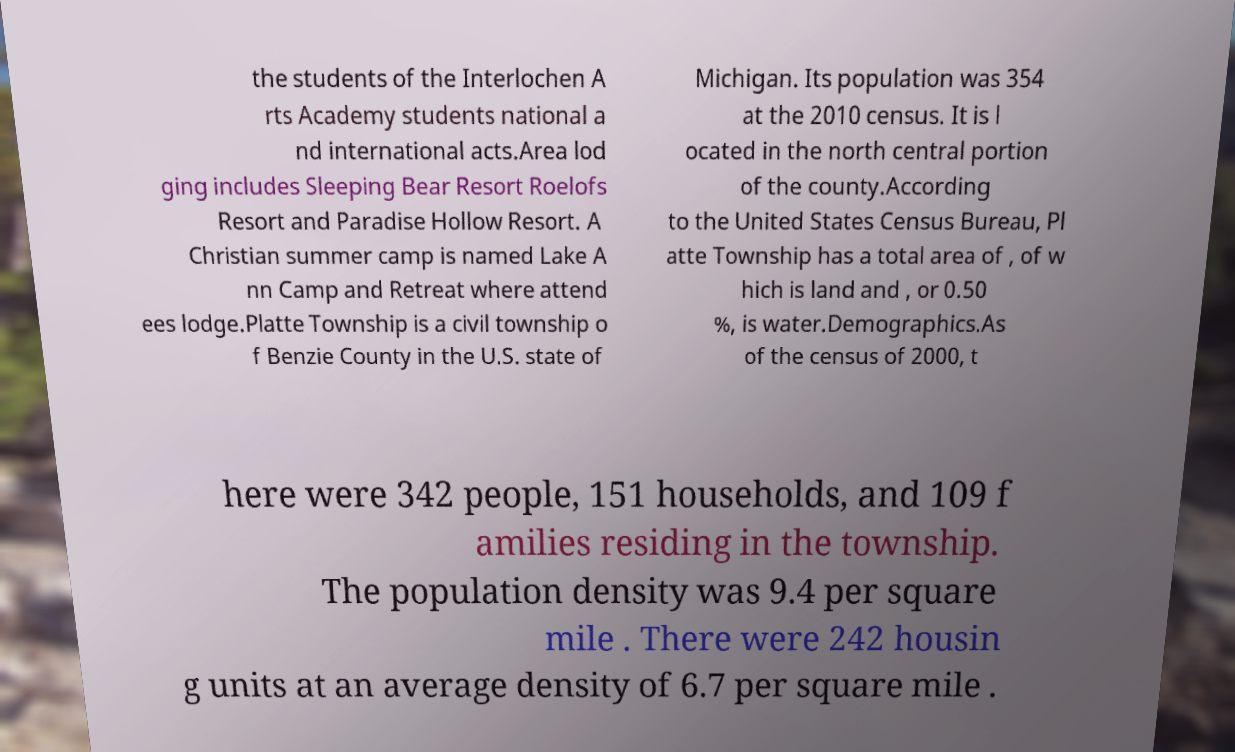Please read and relay the text visible in this image. What does it say? the students of the Interlochen A rts Academy students national a nd international acts.Area lod ging includes Sleeping Bear Resort Roelofs Resort and Paradise Hollow Resort. A Christian summer camp is named Lake A nn Camp and Retreat where attend ees lodge.Platte Township is a civil township o f Benzie County in the U.S. state of Michigan. Its population was 354 at the 2010 census. It is l ocated in the north central portion of the county.According to the United States Census Bureau, Pl atte Township has a total area of , of w hich is land and , or 0.50 %, is water.Demographics.As of the census of 2000, t here were 342 people, 151 households, and 109 f amilies residing in the township. The population density was 9.4 per square mile . There were 242 housin g units at an average density of 6.7 per square mile . 